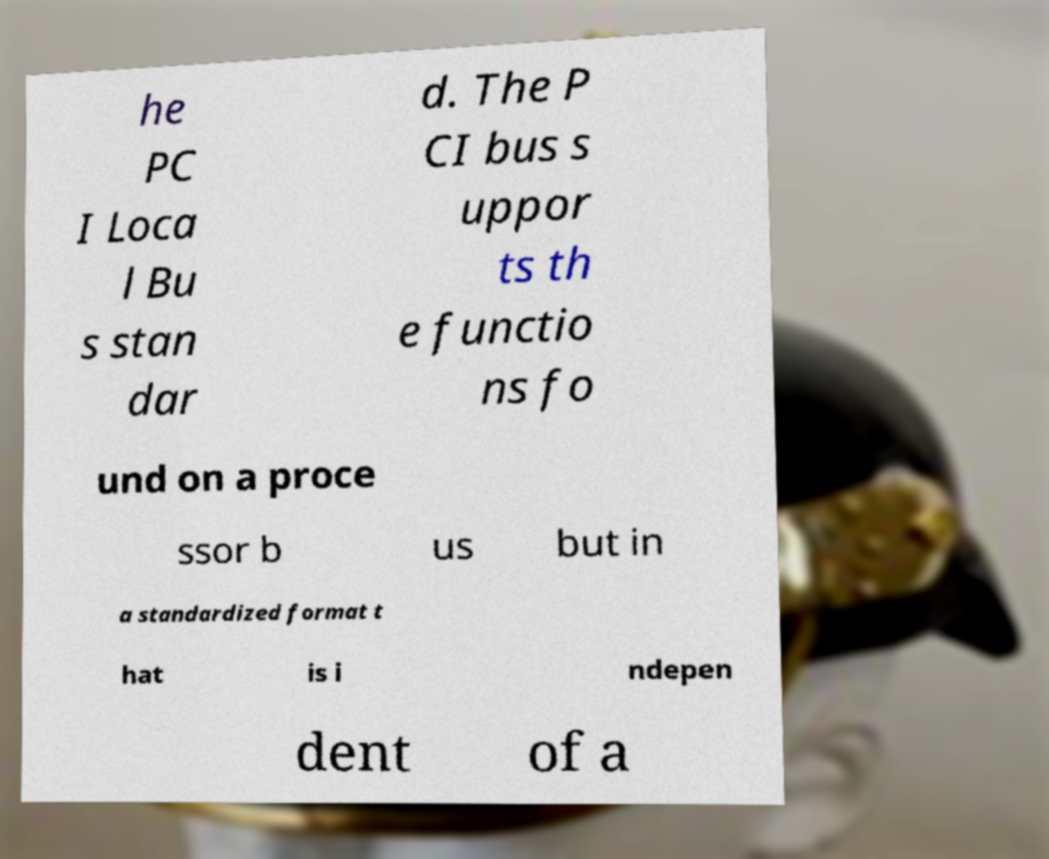Please identify and transcribe the text found in this image. he PC I Loca l Bu s stan dar d. The P CI bus s uppor ts th e functio ns fo und on a proce ssor b us but in a standardized format t hat is i ndepen dent of a 